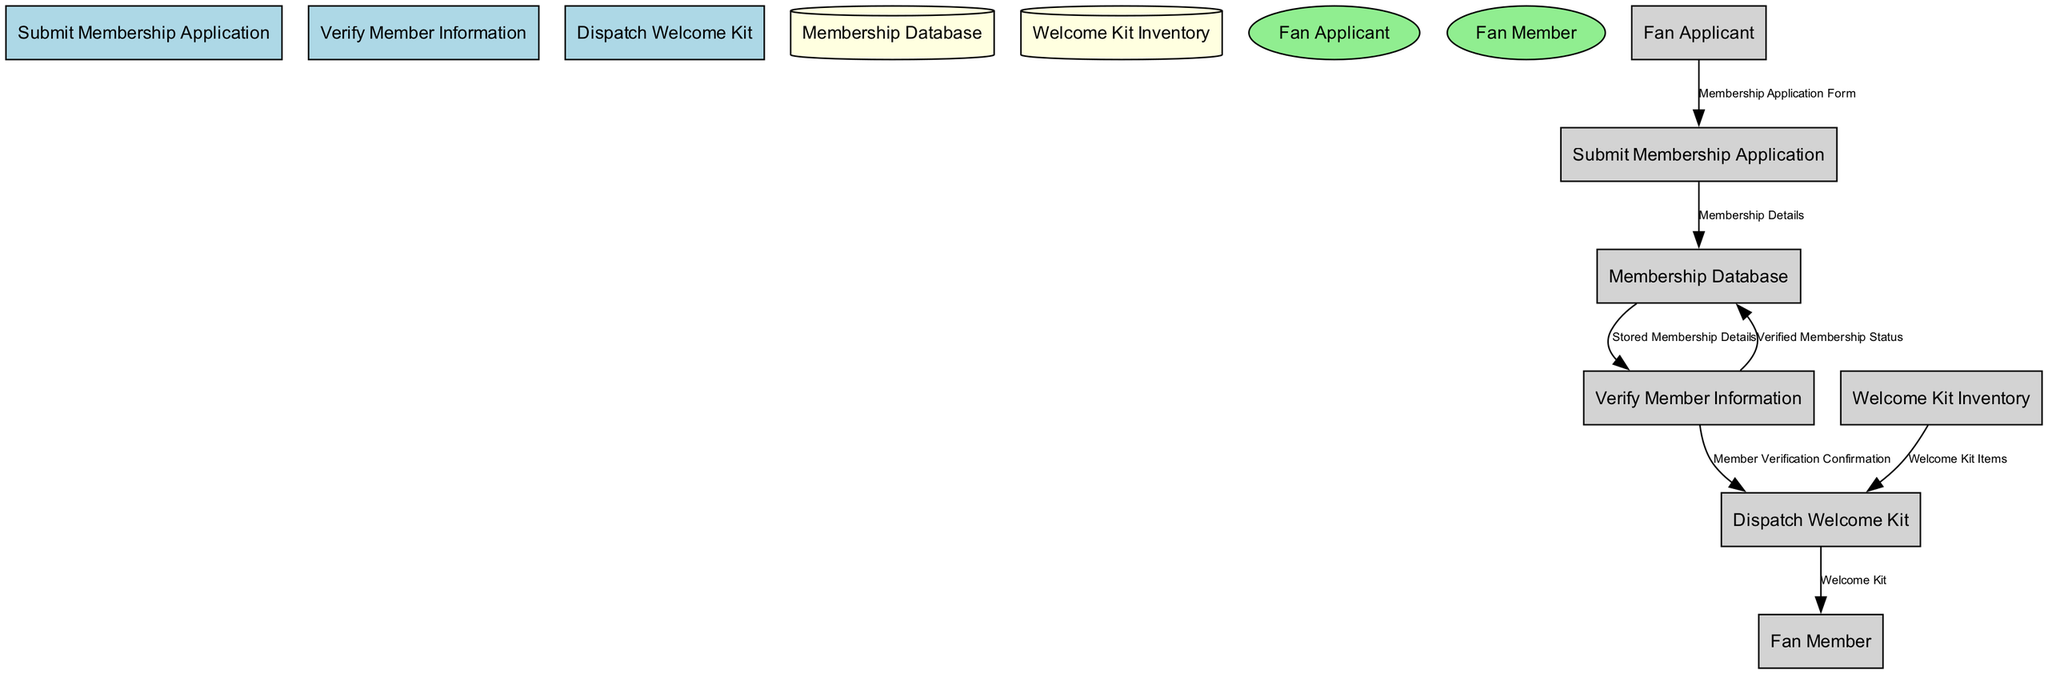What is the first process in the membership enrollment? The diagram shows that the first process is labeled "Submit Membership Application". This can be verified by looking at the list of processes and their order in the diagram.
Answer: Submit Membership Application How many external entities are present in the diagram? There are two external entities in the diagram: "Fan Applicant" and "Fan Member". This is determined by counting the entities listed separately in the external entities section of the diagram.
Answer: 2 What is the data flow coming from the "Submit Membership Application" process to the data store? The data flow from the "Submit Membership Application" process to the data store indicates "Membership Details". This is identified by tracing the directed flow from the process to the membership database in the diagram.
Answer: Membership Details What does the "Verify Member Information" process send back to the Membership Database? The "Verify Member Information" process sends "Verified Membership Status" back to the Membership Database. This is observed from the data flow that goes from the verification process to the data store, specifying the status of verification.
Answer: Verified Membership Status Which external entity receives the welcome kit ultimately? The ultimate recipient of the welcome kit, according to the diagram, is "Fan Member". This is evident as the diagram specifies the data flow leading from the "Dispatch Welcome Kit" process to this external entity.
Answer: Fan Member What is the purpose of the data flow labeled as DF5? The purpose of the data flow labeled DF5 is to indicate the "Member Verification Confirmation" being sent from "Verify Member Information" to "Dispatch Welcome Kit". This illustrates that upon verification, a confirmation is needed before dispatching the welcome kit.
Answer: Member Verification Confirmation How many processes are involved in the membership enrollment process? The diagram includes three distinct processes: "Submit Membership Application", "Verify Member Information", and "Dispatch Welcome Kit". Counting these processes confirms there are three steps in the membership process.
Answer: 3 What items are dispatched in the welcome kit? The items that are dispatched in the welcome kit are labeled "Welcome Kit Items". This is identified in the flow from the welcome kit inventory to the dispatch process within the diagram.
Answer: Welcome Kit Items What is stored in the Membership Database after the application is submitted? After the submission of the application, the information stored in the Membership Database is "Membership Details". This is evident as the data flow shows this specific detail being written into the database from the submission process.
Answer: Membership Details 